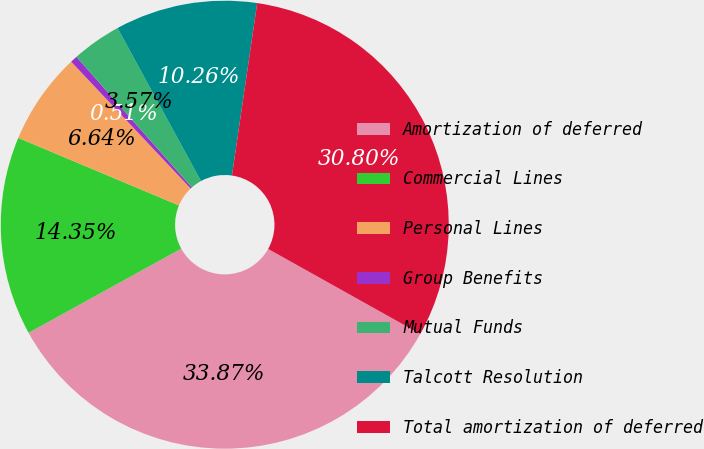Convert chart. <chart><loc_0><loc_0><loc_500><loc_500><pie_chart><fcel>Amortization of deferred<fcel>Commercial Lines<fcel>Personal Lines<fcel>Group Benefits<fcel>Mutual Funds<fcel>Talcott Resolution<fcel>Total amortization of deferred<nl><fcel>33.87%<fcel>14.35%<fcel>6.64%<fcel>0.51%<fcel>3.57%<fcel>10.26%<fcel>30.8%<nl></chart> 